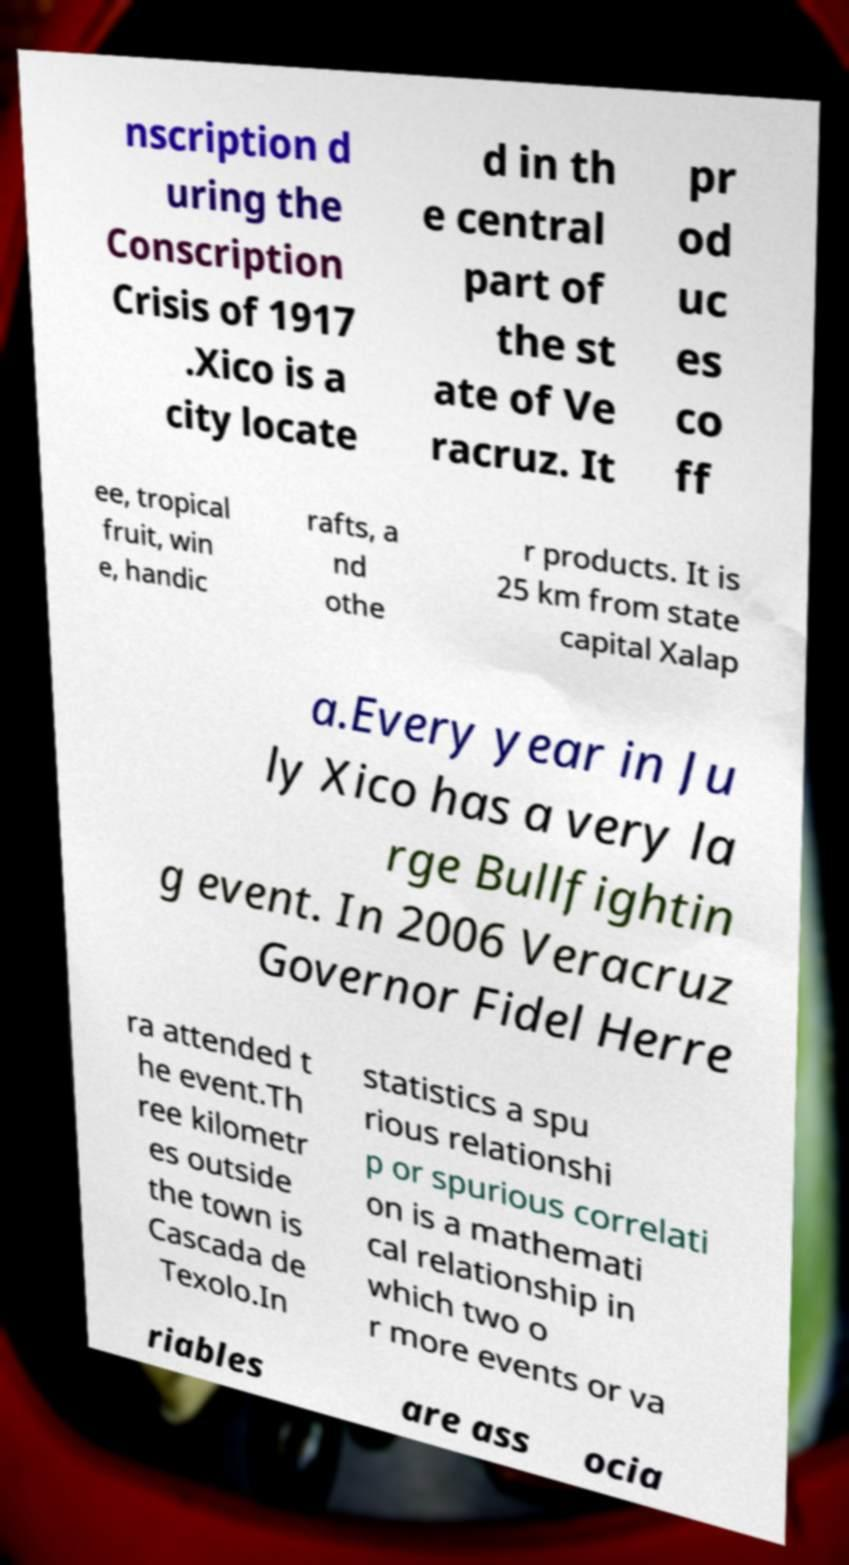Could you extract and type out the text from this image? nscription d uring the Conscription Crisis of 1917 .Xico is a city locate d in th e central part of the st ate of Ve racruz. It pr od uc es co ff ee, tropical fruit, win e, handic rafts, a nd othe r products. It is 25 km from state capital Xalap a.Every year in Ju ly Xico has a very la rge Bullfightin g event. In 2006 Veracruz Governor Fidel Herre ra attended t he event.Th ree kilometr es outside the town is Cascada de Texolo.In statistics a spu rious relationshi p or spurious correlati on is a mathemati cal relationship in which two o r more events or va riables are ass ocia 